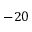Convert formula to latex. <formula><loc_0><loc_0><loc_500><loc_500>- 2 0</formula> 